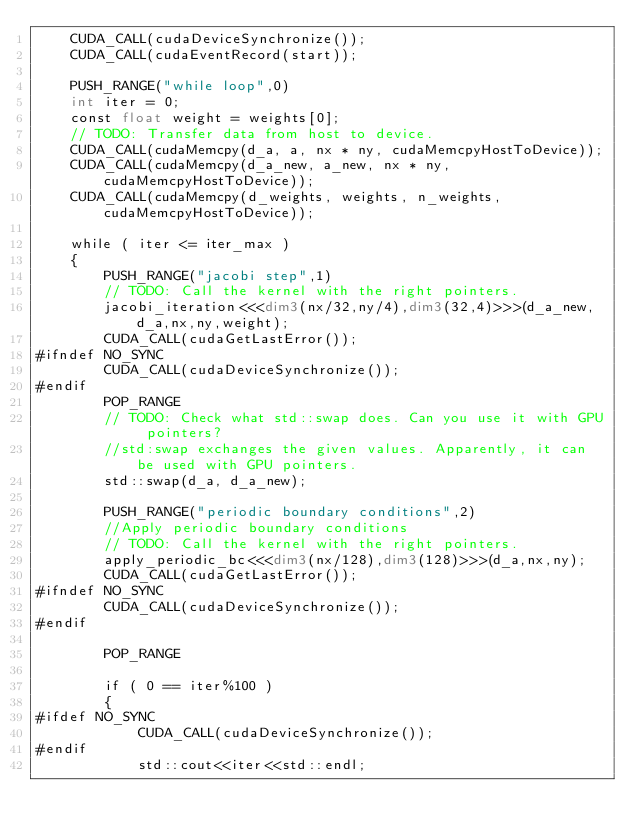Convert code to text. <code><loc_0><loc_0><loc_500><loc_500><_Cuda_>    CUDA_CALL(cudaDeviceSynchronize());
    CUDA_CALL(cudaEventRecord(start));
    
    PUSH_RANGE("while loop",0)
    int iter = 0;
    const float weight = weights[0];
    // TODO: Transfer data from host to device.
    CUDA_CALL(cudaMemcpy(d_a, a, nx * ny, cudaMemcpyHostToDevice));
    CUDA_CALL(cudaMemcpy(d_a_new, a_new, nx * ny, cudaMemcpyHostToDevice));
    CUDA_CALL(cudaMemcpy(d_weights, weights, n_weights, cudaMemcpyHostToDevice));

    while ( iter <= iter_max )
    {
        PUSH_RANGE("jacobi step",1)
        // TODO: Call the kernel with the right pointers.
        jacobi_iteration<<<dim3(nx/32,ny/4),dim3(32,4)>>>(d_a_new,d_a,nx,ny,weight);
        CUDA_CALL(cudaGetLastError());
#ifndef NO_SYNC
        CUDA_CALL(cudaDeviceSynchronize());
#endif
        POP_RANGE
        // TODO: Check what std::swap does. Can you use it with GPU pointers?
        //std:swap exchanges the given values. Apparently, it can be used with GPU pointers.
        std::swap(d_a, d_a_new);
        
        PUSH_RANGE("periodic boundary conditions",2)
        //Apply periodic boundary conditions
        // TODO: Call the kernel with the right pointers.
        apply_periodic_bc<<<dim3(nx/128),dim3(128)>>>(d_a,nx,ny);
        CUDA_CALL(cudaGetLastError());
#ifndef NO_SYNC
        CUDA_CALL(cudaDeviceSynchronize());
#endif
        
        POP_RANGE
        
        if ( 0 == iter%100 )
        {
#ifdef NO_SYNC
            CUDA_CALL(cudaDeviceSynchronize());
#endif
            std::cout<<iter<<std::endl;</code> 